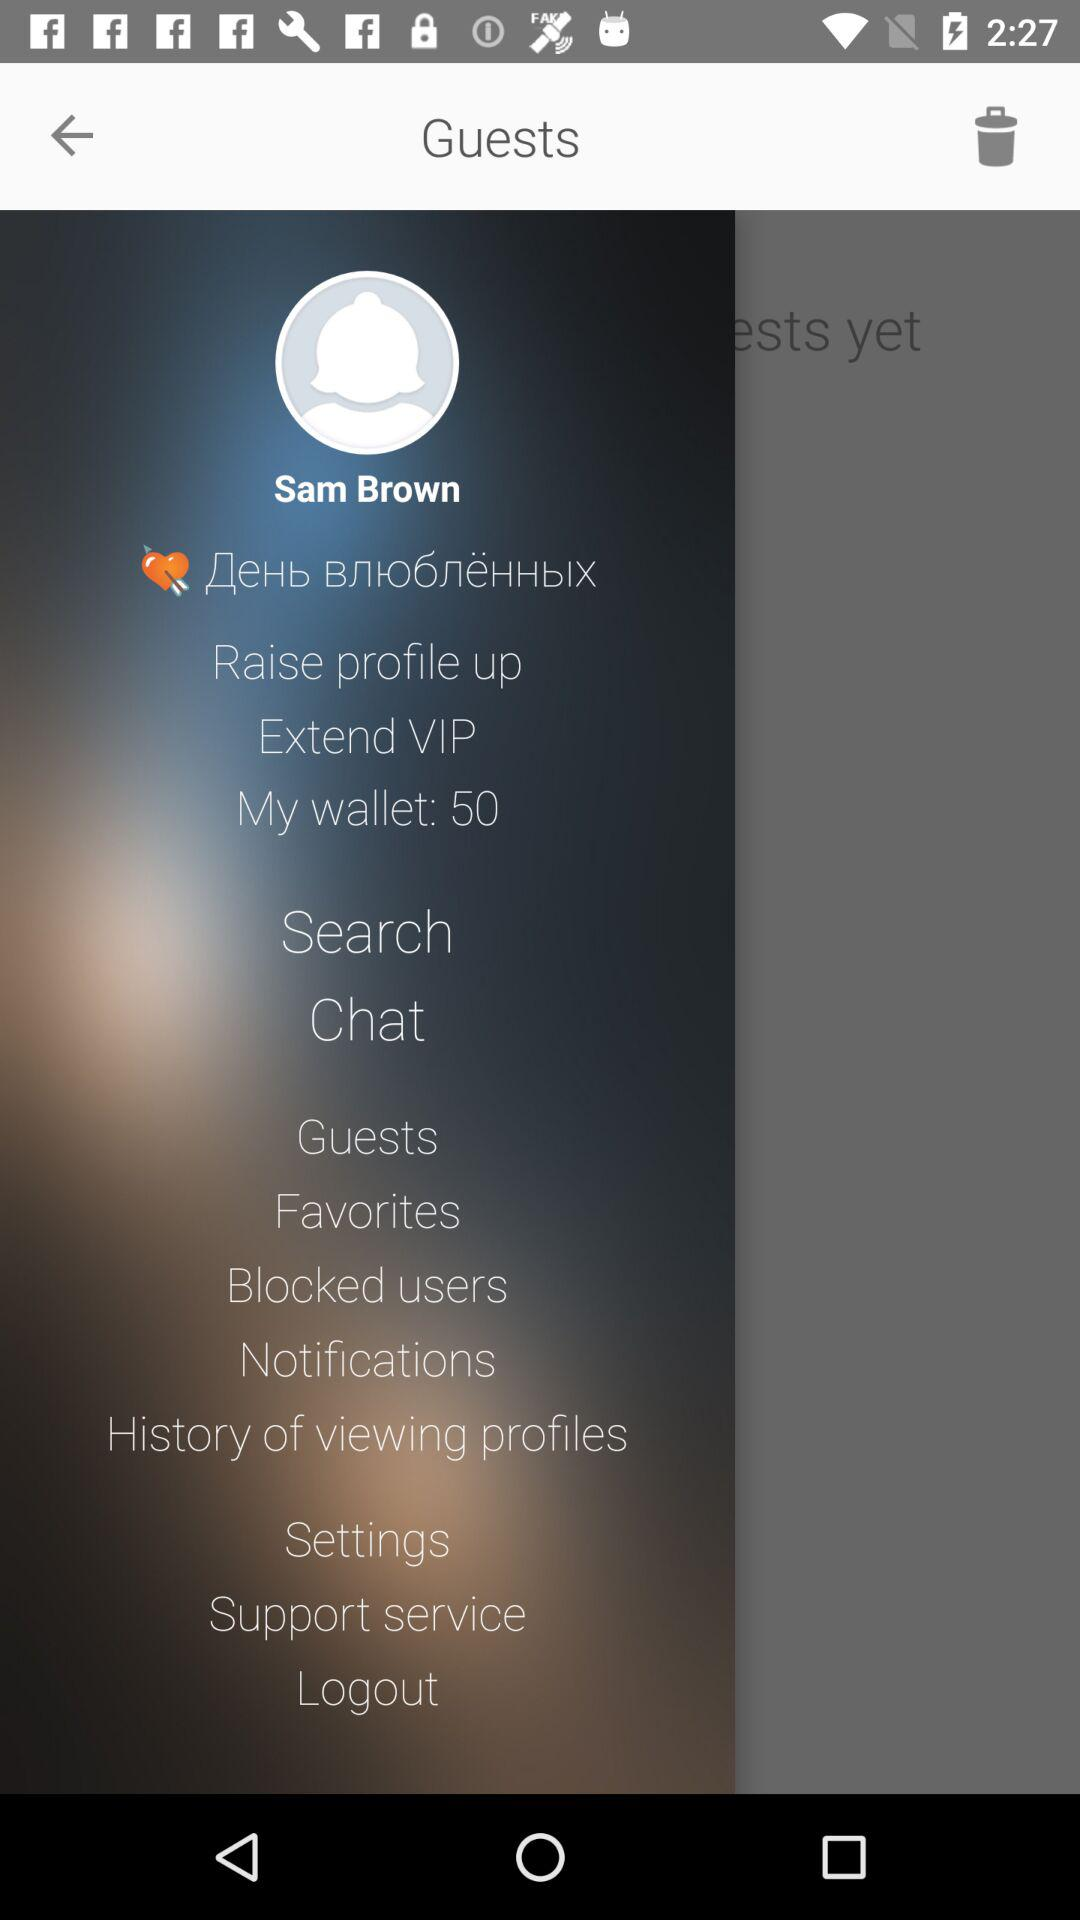What is the count in "My wallet"? The count in "My wallet" is 50. 